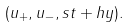Convert formula to latex. <formula><loc_0><loc_0><loc_500><loc_500>( u _ { + } , u _ { - } , s t + h y ) .</formula> 